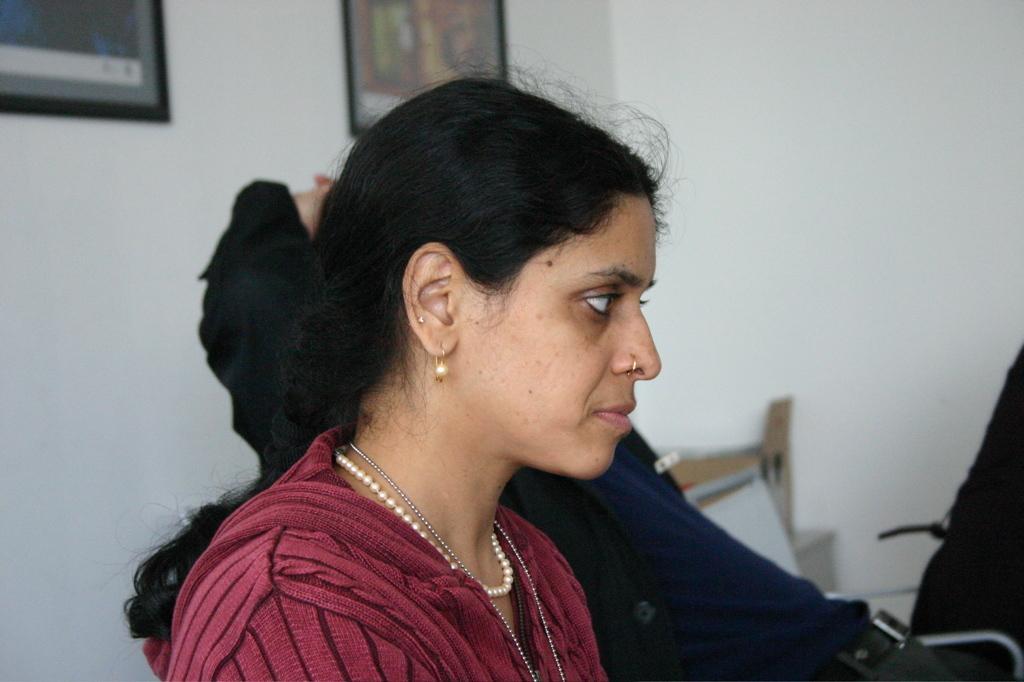Could you give a brief overview of what you see in this image? In this image, we can see people sitting on the chairs and one of them is wearing a nose pin and some chains. In the background, there are frames on the wall and we can see a table and some objects. 